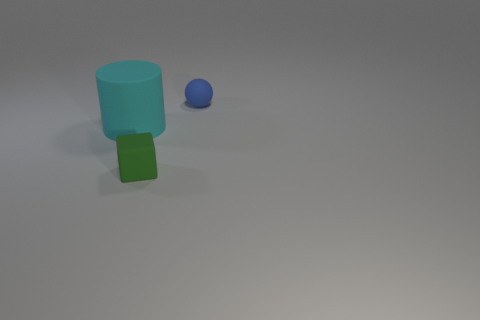What number of other things are there of the same material as the sphere
Offer a terse response. 2. Is the green block the same size as the matte cylinder?
Provide a succinct answer. No. What is the shape of the rubber object left of the tiny green matte cube?
Offer a very short reply. Cylinder. What is the color of the small object right of the small object that is in front of the blue matte ball?
Your response must be concise. Blue. There is a matte object behind the cyan cylinder; does it have the same shape as the tiny rubber thing in front of the tiny blue thing?
Make the answer very short. No. What shape is the blue rubber object that is the same size as the green object?
Your answer should be very brief. Sphere. There is a large object that is the same material as the sphere; what is its color?
Provide a short and direct response. Cyan. There is a large object; does it have the same shape as the small rubber thing on the left side of the matte sphere?
Provide a succinct answer. No. There is a object that is the same size as the green block; what is its material?
Offer a very short reply. Rubber. There is a object that is both on the right side of the large rubber thing and behind the small green matte thing; what is its shape?
Offer a very short reply. Sphere. 